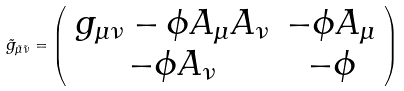<formula> <loc_0><loc_0><loc_500><loc_500>\tilde { g } _ { \tilde { \mu } \tilde { \nu } } = \left ( \begin{array} { c c c } g _ { \mu \nu } - \phi A _ { \mu } A _ { \nu } & - \phi A _ { \mu } \\ - \phi A _ { \nu } & - \phi \end{array} \right )</formula> 